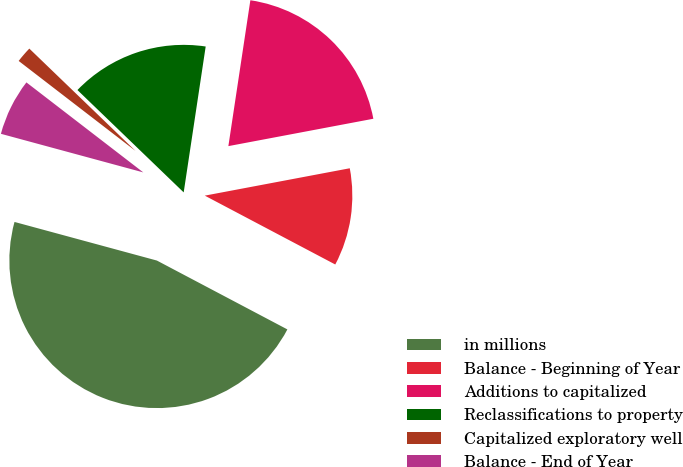Convert chart. <chart><loc_0><loc_0><loc_500><loc_500><pie_chart><fcel>in millions<fcel>Balance - Beginning of Year<fcel>Additions to capitalized<fcel>Reclassifications to property<fcel>Capitalized exploratory well<fcel>Balance - End of Year<nl><fcel>46.49%<fcel>10.7%<fcel>19.65%<fcel>15.18%<fcel>1.76%<fcel>6.23%<nl></chart> 